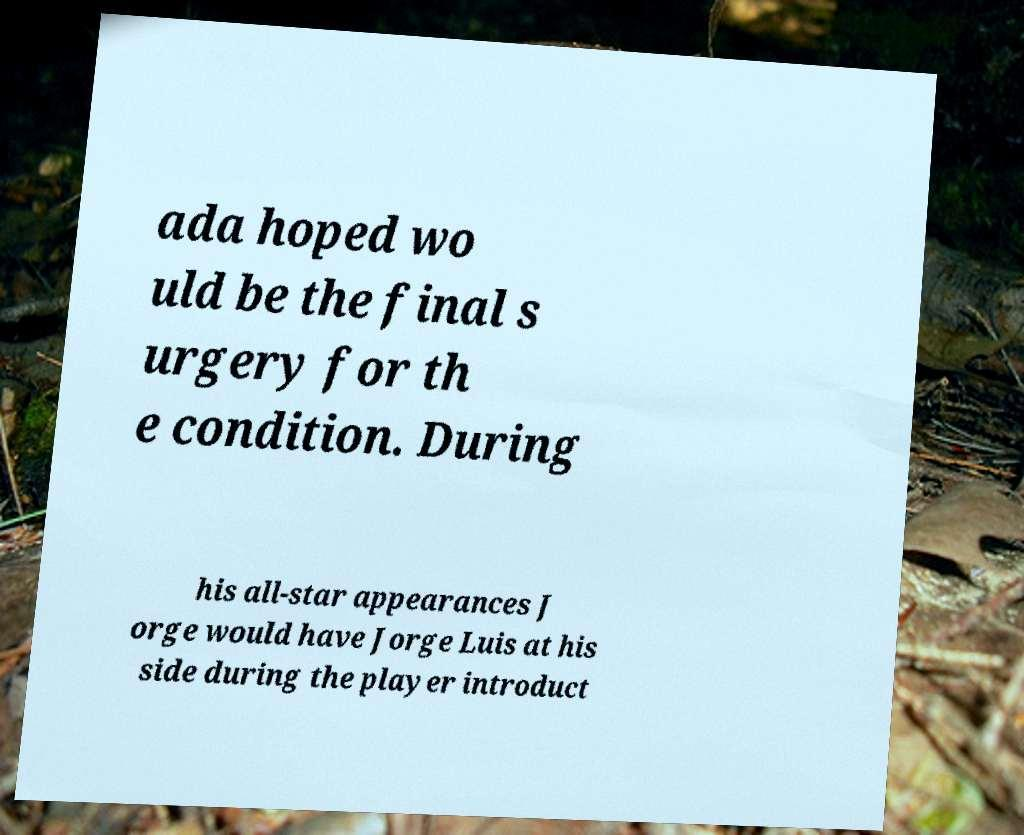Could you assist in decoding the text presented in this image and type it out clearly? ada hoped wo uld be the final s urgery for th e condition. During his all-star appearances J orge would have Jorge Luis at his side during the player introduct 